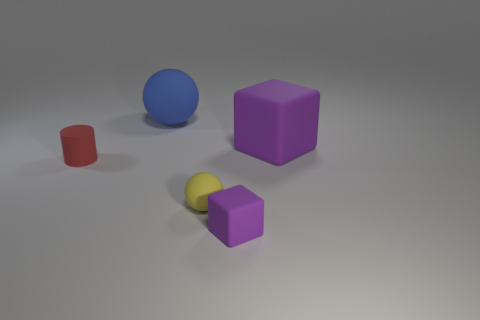Add 1 matte objects. How many objects exist? 6 Subtract all spheres. How many objects are left? 3 Subtract all yellow cylinders. How many cyan cubes are left? 0 Subtract all yellow balls. How many balls are left? 1 Subtract all purple spheres. Subtract all red cylinders. How many spheres are left? 2 Add 1 small cylinders. How many small cylinders exist? 2 Subtract 0 brown cubes. How many objects are left? 5 Subtract all large red blocks. Subtract all tiny balls. How many objects are left? 4 Add 5 tiny rubber objects. How many tiny rubber objects are left? 8 